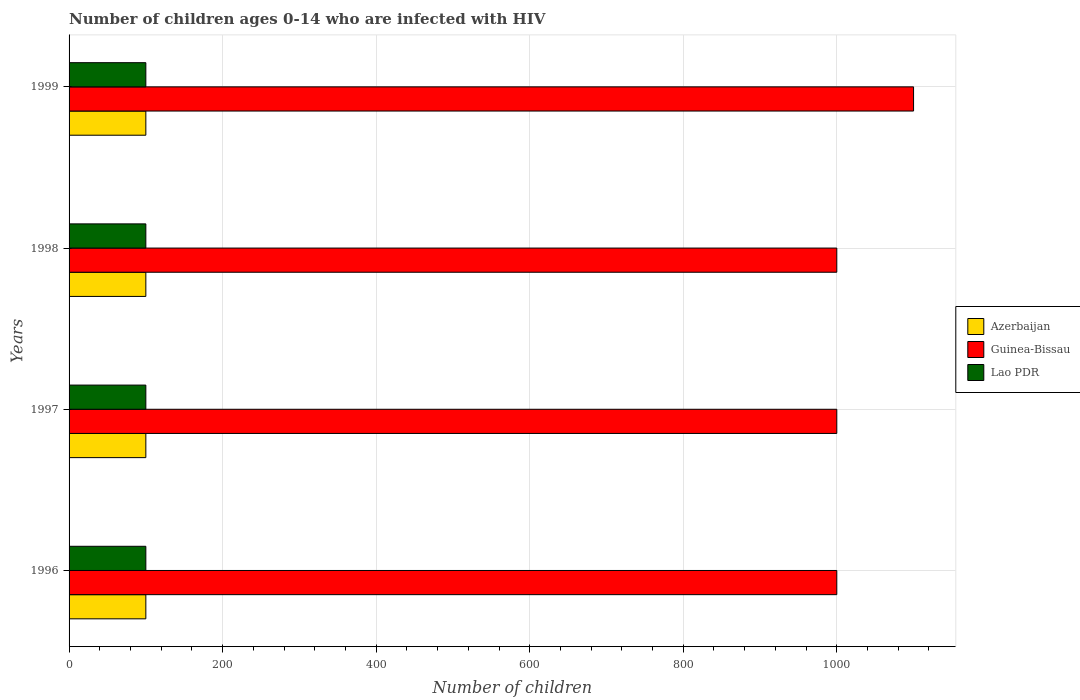How many groups of bars are there?
Your answer should be compact. 4. Are the number of bars per tick equal to the number of legend labels?
Keep it short and to the point. Yes. How many bars are there on the 3rd tick from the top?
Your answer should be very brief. 3. How many bars are there on the 3rd tick from the bottom?
Your answer should be compact. 3. What is the number of HIV infected children in Lao PDR in 1996?
Give a very brief answer. 100. Across all years, what is the maximum number of HIV infected children in Lao PDR?
Provide a short and direct response. 100. Across all years, what is the minimum number of HIV infected children in Azerbaijan?
Provide a short and direct response. 100. In which year was the number of HIV infected children in Lao PDR minimum?
Your response must be concise. 1996. What is the total number of HIV infected children in Guinea-Bissau in the graph?
Provide a succinct answer. 4100. What is the difference between the number of HIV infected children in Lao PDR in 1996 and that in 1999?
Your response must be concise. 0. What is the difference between the number of HIV infected children in Lao PDR in 1998 and the number of HIV infected children in Azerbaijan in 1999?
Offer a terse response. 0. What is the average number of HIV infected children in Azerbaijan per year?
Your answer should be compact. 100. In the year 1999, what is the difference between the number of HIV infected children in Lao PDR and number of HIV infected children in Guinea-Bissau?
Provide a short and direct response. -1000. What is the ratio of the number of HIV infected children in Guinea-Bissau in 1997 to that in 1999?
Ensure brevity in your answer.  0.91. Is the number of HIV infected children in Lao PDR in 1996 less than that in 1997?
Make the answer very short. No. What is the difference between the highest and the lowest number of HIV infected children in Lao PDR?
Make the answer very short. 0. In how many years, is the number of HIV infected children in Lao PDR greater than the average number of HIV infected children in Lao PDR taken over all years?
Make the answer very short. 0. What does the 3rd bar from the top in 1996 represents?
Offer a terse response. Azerbaijan. What does the 2nd bar from the bottom in 1996 represents?
Keep it short and to the point. Guinea-Bissau. Is it the case that in every year, the sum of the number of HIV infected children in Azerbaijan and number of HIV infected children in Lao PDR is greater than the number of HIV infected children in Guinea-Bissau?
Keep it short and to the point. No. How many bars are there?
Your answer should be compact. 12. How many years are there in the graph?
Ensure brevity in your answer.  4. What is the difference between two consecutive major ticks on the X-axis?
Keep it short and to the point. 200. Are the values on the major ticks of X-axis written in scientific E-notation?
Your answer should be very brief. No. Where does the legend appear in the graph?
Make the answer very short. Center right. What is the title of the graph?
Your answer should be compact. Number of children ages 0-14 who are infected with HIV. What is the label or title of the X-axis?
Offer a terse response. Number of children. What is the Number of children in Lao PDR in 1996?
Give a very brief answer. 100. What is the Number of children in Azerbaijan in 1997?
Your response must be concise. 100. What is the Number of children of Azerbaijan in 1998?
Your answer should be compact. 100. What is the Number of children of Guinea-Bissau in 1999?
Give a very brief answer. 1100. What is the Number of children of Lao PDR in 1999?
Offer a very short reply. 100. Across all years, what is the maximum Number of children in Azerbaijan?
Your answer should be compact. 100. Across all years, what is the maximum Number of children of Guinea-Bissau?
Provide a succinct answer. 1100. Across all years, what is the minimum Number of children in Lao PDR?
Offer a very short reply. 100. What is the total Number of children in Azerbaijan in the graph?
Provide a succinct answer. 400. What is the total Number of children in Guinea-Bissau in the graph?
Keep it short and to the point. 4100. What is the difference between the Number of children of Azerbaijan in 1996 and that in 1998?
Give a very brief answer. 0. What is the difference between the Number of children of Guinea-Bissau in 1996 and that in 1998?
Your response must be concise. 0. What is the difference between the Number of children in Guinea-Bissau in 1996 and that in 1999?
Your answer should be compact. -100. What is the difference between the Number of children in Lao PDR in 1996 and that in 1999?
Your answer should be very brief. 0. What is the difference between the Number of children of Guinea-Bissau in 1997 and that in 1998?
Your answer should be compact. 0. What is the difference between the Number of children of Lao PDR in 1997 and that in 1998?
Make the answer very short. 0. What is the difference between the Number of children in Azerbaijan in 1997 and that in 1999?
Provide a short and direct response. 0. What is the difference between the Number of children of Guinea-Bissau in 1997 and that in 1999?
Keep it short and to the point. -100. What is the difference between the Number of children in Lao PDR in 1997 and that in 1999?
Provide a succinct answer. 0. What is the difference between the Number of children of Guinea-Bissau in 1998 and that in 1999?
Make the answer very short. -100. What is the difference between the Number of children of Azerbaijan in 1996 and the Number of children of Guinea-Bissau in 1997?
Your answer should be compact. -900. What is the difference between the Number of children of Azerbaijan in 1996 and the Number of children of Lao PDR in 1997?
Provide a short and direct response. 0. What is the difference between the Number of children in Guinea-Bissau in 1996 and the Number of children in Lao PDR in 1997?
Your answer should be very brief. 900. What is the difference between the Number of children of Azerbaijan in 1996 and the Number of children of Guinea-Bissau in 1998?
Keep it short and to the point. -900. What is the difference between the Number of children of Azerbaijan in 1996 and the Number of children of Lao PDR in 1998?
Provide a succinct answer. 0. What is the difference between the Number of children in Guinea-Bissau in 1996 and the Number of children in Lao PDR in 1998?
Give a very brief answer. 900. What is the difference between the Number of children of Azerbaijan in 1996 and the Number of children of Guinea-Bissau in 1999?
Your response must be concise. -1000. What is the difference between the Number of children of Guinea-Bissau in 1996 and the Number of children of Lao PDR in 1999?
Your response must be concise. 900. What is the difference between the Number of children of Azerbaijan in 1997 and the Number of children of Guinea-Bissau in 1998?
Offer a terse response. -900. What is the difference between the Number of children in Azerbaijan in 1997 and the Number of children in Lao PDR in 1998?
Give a very brief answer. 0. What is the difference between the Number of children of Guinea-Bissau in 1997 and the Number of children of Lao PDR in 1998?
Your answer should be compact. 900. What is the difference between the Number of children in Azerbaijan in 1997 and the Number of children in Guinea-Bissau in 1999?
Your response must be concise. -1000. What is the difference between the Number of children in Guinea-Bissau in 1997 and the Number of children in Lao PDR in 1999?
Your response must be concise. 900. What is the difference between the Number of children of Azerbaijan in 1998 and the Number of children of Guinea-Bissau in 1999?
Make the answer very short. -1000. What is the difference between the Number of children in Guinea-Bissau in 1998 and the Number of children in Lao PDR in 1999?
Offer a very short reply. 900. What is the average Number of children in Guinea-Bissau per year?
Provide a succinct answer. 1025. What is the average Number of children in Lao PDR per year?
Offer a terse response. 100. In the year 1996, what is the difference between the Number of children in Azerbaijan and Number of children in Guinea-Bissau?
Offer a terse response. -900. In the year 1996, what is the difference between the Number of children in Azerbaijan and Number of children in Lao PDR?
Your response must be concise. 0. In the year 1996, what is the difference between the Number of children in Guinea-Bissau and Number of children in Lao PDR?
Make the answer very short. 900. In the year 1997, what is the difference between the Number of children in Azerbaijan and Number of children in Guinea-Bissau?
Give a very brief answer. -900. In the year 1997, what is the difference between the Number of children of Guinea-Bissau and Number of children of Lao PDR?
Your answer should be very brief. 900. In the year 1998, what is the difference between the Number of children of Azerbaijan and Number of children of Guinea-Bissau?
Ensure brevity in your answer.  -900. In the year 1998, what is the difference between the Number of children of Guinea-Bissau and Number of children of Lao PDR?
Your response must be concise. 900. In the year 1999, what is the difference between the Number of children in Azerbaijan and Number of children in Guinea-Bissau?
Provide a short and direct response. -1000. In the year 1999, what is the difference between the Number of children of Guinea-Bissau and Number of children of Lao PDR?
Keep it short and to the point. 1000. What is the ratio of the Number of children in Guinea-Bissau in 1996 to that in 1998?
Your answer should be compact. 1. What is the ratio of the Number of children in Lao PDR in 1996 to that in 1998?
Offer a very short reply. 1. What is the ratio of the Number of children in Lao PDR in 1996 to that in 1999?
Your response must be concise. 1. What is the ratio of the Number of children in Azerbaijan in 1997 to that in 1998?
Offer a terse response. 1. What is the ratio of the Number of children of Guinea-Bissau in 1997 to that in 1998?
Give a very brief answer. 1. What is the ratio of the Number of children in Lao PDR in 1997 to that in 1998?
Provide a short and direct response. 1. What is the ratio of the Number of children of Azerbaijan in 1997 to that in 1999?
Offer a terse response. 1. What is the ratio of the Number of children of Lao PDR in 1997 to that in 1999?
Give a very brief answer. 1. What is the ratio of the Number of children in Guinea-Bissau in 1998 to that in 1999?
Your answer should be very brief. 0.91. What is the difference between the highest and the second highest Number of children in Lao PDR?
Offer a terse response. 0. What is the difference between the highest and the lowest Number of children of Azerbaijan?
Offer a very short reply. 0. What is the difference between the highest and the lowest Number of children in Guinea-Bissau?
Your answer should be compact. 100. 